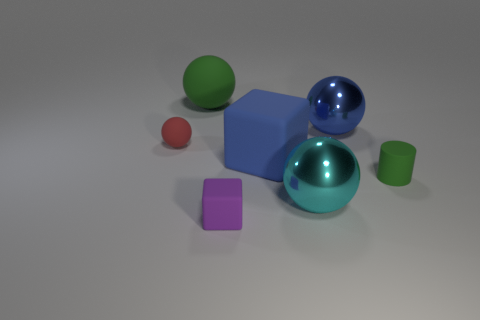Add 1 small green matte objects. How many objects exist? 8 Subtract all balls. How many objects are left? 3 Add 3 big purple spheres. How many big purple spheres exist? 3 Subtract 1 red spheres. How many objects are left? 6 Subtract all large brown spheres. Subtract all large rubber balls. How many objects are left? 6 Add 7 tiny objects. How many tiny objects are left? 10 